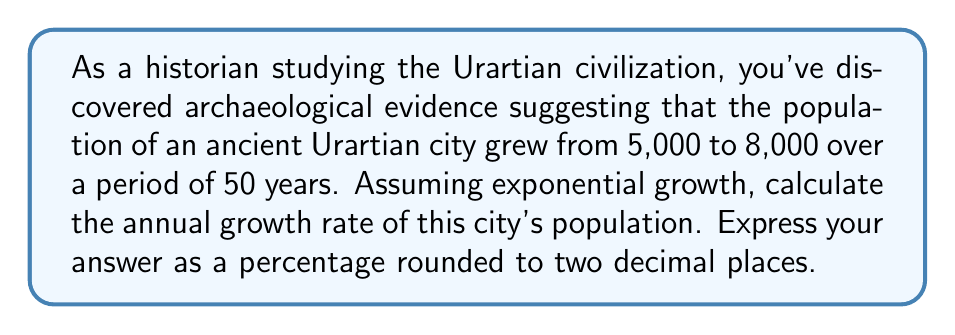Could you help me with this problem? To solve this problem, we'll use the exponential growth formula:

$$A = P(1 + r)^t$$

Where:
$A$ = Final amount (population)
$P$ = Initial amount (population)
$r$ = Annual growth rate (in decimal form)
$t$ = Time period (in years)

Given:
$P = 5,000$ (initial population)
$A = 8,000$ (final population)
$t = 50$ years

Step 1: Plug the known values into the formula:
$$8,000 = 5,000(1 + r)^{50}$$

Step 2: Divide both sides by 5,000:
$$\frac{8,000}{5,000} = (1 + r)^{50}$$
$$1.6 = (1 + r)^{50}$$

Step 3: Take the 50th root of both sides:
$$\sqrt[50]{1.6} = 1 + r$$

Step 4: Subtract 1 from both sides:
$$\sqrt[50]{1.6} - 1 = r$$

Step 5: Calculate the value of $r$:
$$r \approx 0.009544$$

Step 6: Convert to a percentage by multiplying by 100:
$$0.009544 \times 100 \approx 0.9544\%$$

Step 7: Round to two decimal places:
$$0.95\%$$
Answer: The annual population growth rate of the ancient Urartian city was approximately 0.95%. 